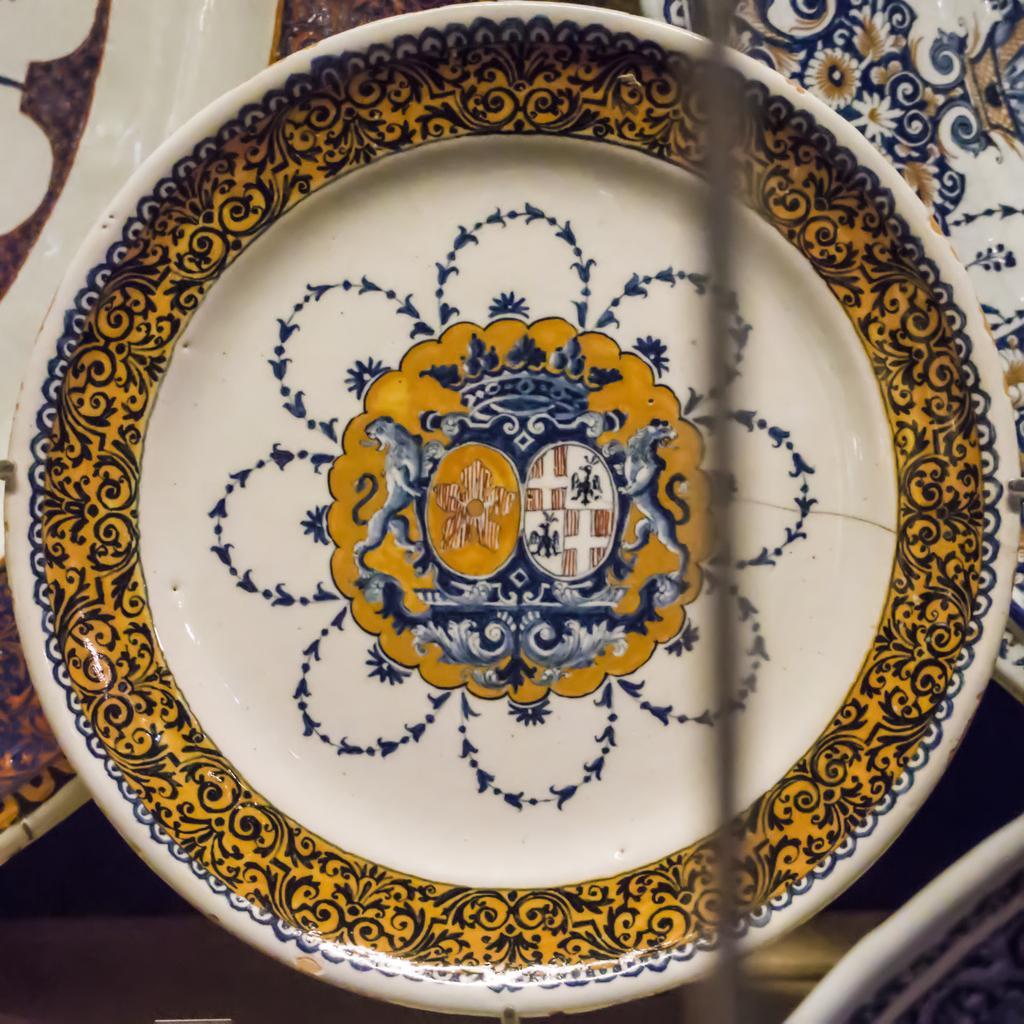In one or two sentences, can you explain what this image depicts? In this image we can see some plates with images on the surface which looks like a floor. 